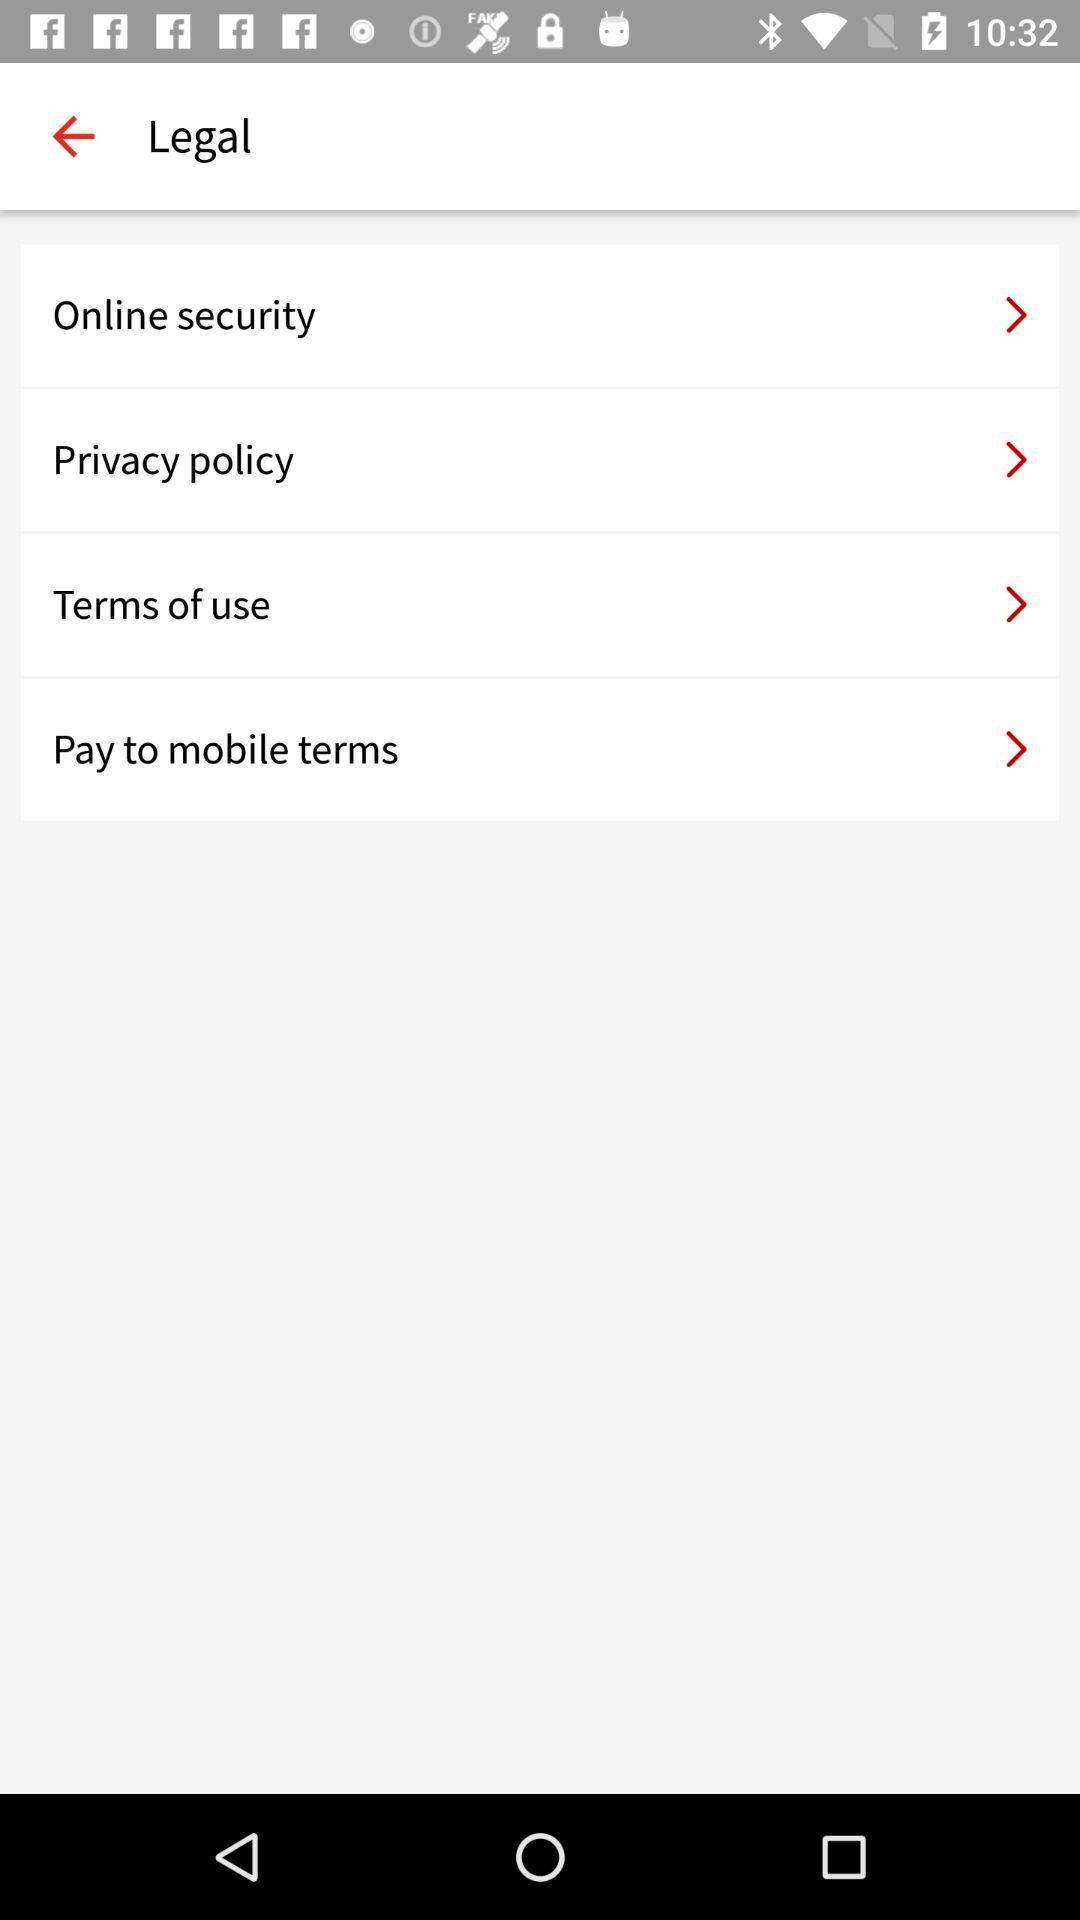Why is it important to read these terms of service? Reading these terms of service is crucial because they contain important information about your rights and responsibilities as a user. They govern your use of the service, explain how your personal information is protected, detail the security measures in place, and outline any financial obligations or conditions associated with mobile payments. 